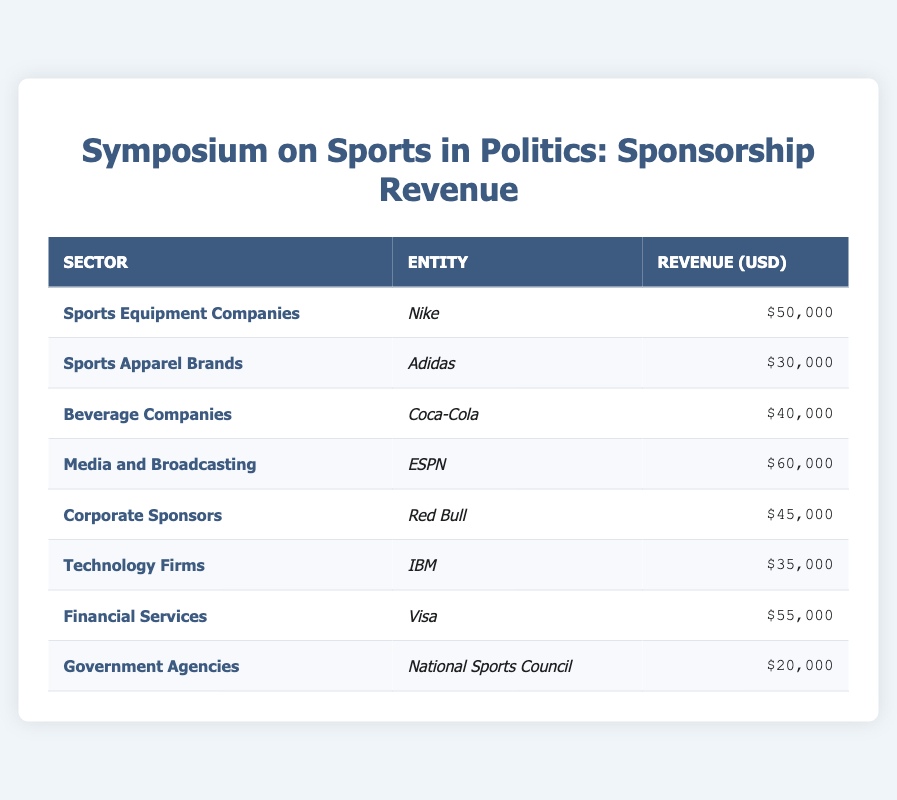What is the total revenue from the Media and Broadcasting sector? From the table, the Media and Broadcasting sector is represented by the entity ESPN, which has a revenue of $60,000. Therefore, the total revenue from this sector is $60,000.
Answer: $60,000 Which entity contributed the highest revenue among the sponsorship sources? By reviewing the revenue values, Nike contributes $50,000, Adidas $30,000, Coca-Cola $40,000, ESPN $60,000, Red Bull $45,000, IBM $35,000, Visa $55,000, and the National Sports Council $20,000. ESPN has the highest revenue of $60,000.
Answer: ESPN What is the revenue difference between Financial Services and Corporate Sponsors? The revenue from Financial Services (Visa) is $55,000 and from Corporate Sponsors (Red Bull) is $45,000. The difference is calculated as $55,000 - $45,000 = $10,000.
Answer: $10,000 Is the revenue from Government Agencies greater than that from Sports Apparel Brands? The revenue from Government Agencies (National Sports Council) is $20,000 and from Sports Apparel Brands (Adidas) is $30,000. Since $20,000 is not greater than $30,000, the answer is no.
Answer: No What is the average revenue across all sponsorship sectors? To find the average, sum the revenues: $50,000 + $30,000 + $40,000 + $60,000 + $45,000 + $35,000 + $55,000 + $20,000 = $335,000. There are 8 entities, so the average revenue is $335,000 / 8 = $41,875.
Answer: $41,875 Which sector has the lowest revenue, and what is that revenue? The sector with the lowest revenue is Government Agencies, specifically represented by the National Sports Council, which has a revenue of $20,000.
Answer: Government Agencies, $20,000 How much total revenue did the Beverage Companies and Sports Apparel Brands generate combined? Beverage Companies (Coca-Cola) generated $40,000 and Sports Apparel Brands (Adidas) generated $30,000. The combined revenue is $40,000 + $30,000 = $70,000.
Answer: $70,000 Which sectors contributed over $50,000 in revenue? By examining the revenue amounts, the sectors that contributed over $50,000 are Media and Broadcasting (ESPN) with $60,000 and Financial Services (Visa) with $55,000.
Answer: Media and Broadcasting, Financial Services 